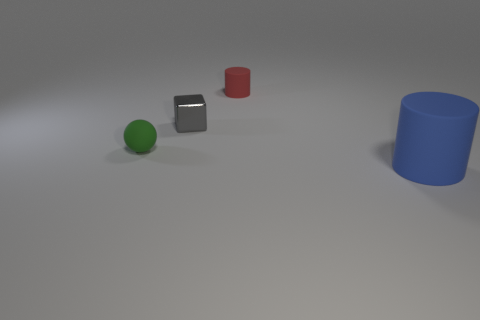Are there an equal number of gray cubes in front of the gray block and blue metal balls?
Your answer should be very brief. Yes. How many other metallic things are the same shape as the small red thing?
Keep it short and to the point. 0. Is the shape of the large blue matte thing the same as the red object?
Offer a very short reply. Yes. What number of objects are either small objects in front of the small gray object or big brown shiny cylinders?
Offer a terse response. 1. What shape is the rubber object in front of the rubber object left of the cylinder that is to the left of the large matte object?
Provide a succinct answer. Cylinder. The tiny object that is the same material as the tiny red cylinder is what shape?
Make the answer very short. Sphere. What is the size of the green rubber object?
Offer a very short reply. Small. Does the gray cube have the same size as the blue cylinder?
Offer a very short reply. No. How many things are either things behind the large matte thing or things that are on the right side of the gray shiny cube?
Ensure brevity in your answer.  4. How many cylinders are to the left of the rubber cylinder in front of the rubber cylinder on the left side of the big cylinder?
Make the answer very short. 1. 